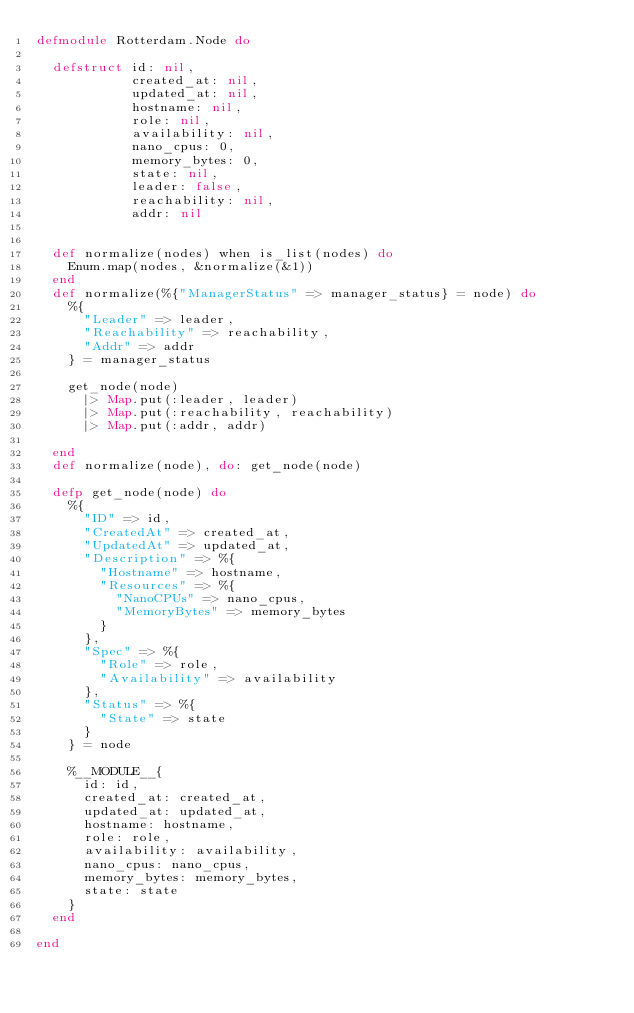Convert code to text. <code><loc_0><loc_0><loc_500><loc_500><_Elixir_>defmodule Rotterdam.Node do

  defstruct id: nil,
            created_at: nil,
            updated_at: nil,
            hostname: nil,
            role: nil,
            availability: nil,
            nano_cpus: 0,
            memory_bytes: 0,
            state: nil,
            leader: false,
            reachability: nil,
            addr: nil


  def normalize(nodes) when is_list(nodes) do
    Enum.map(nodes, &normalize(&1))
  end
  def normalize(%{"ManagerStatus" => manager_status} = node) do
    %{
      "Leader" => leader,
      "Reachability" => reachability,
      "Addr" => addr
    } = manager_status

    get_node(node)
      |> Map.put(:leader, leader)
      |> Map.put(:reachability, reachability)
      |> Map.put(:addr, addr)

  end
  def normalize(node), do: get_node(node)

  defp get_node(node) do
    %{
      "ID" => id,
      "CreatedAt" => created_at,
      "UpdatedAt" => updated_at,
      "Description" => %{
        "Hostname" => hostname,
        "Resources" => %{
          "NanoCPUs" => nano_cpus,
          "MemoryBytes" => memory_bytes
        }
      },
      "Spec" => %{
        "Role" => role,
        "Availability" => availability
      },
      "Status" => %{
        "State" => state
      }
    } = node

    %__MODULE__{
      id: id,
      created_at: created_at,
      updated_at: updated_at,
      hostname: hostname,
      role: role,
      availability: availability,
      nano_cpus: nano_cpus,
      memory_bytes: memory_bytes,
      state: state
    }
  end

end
</code> 